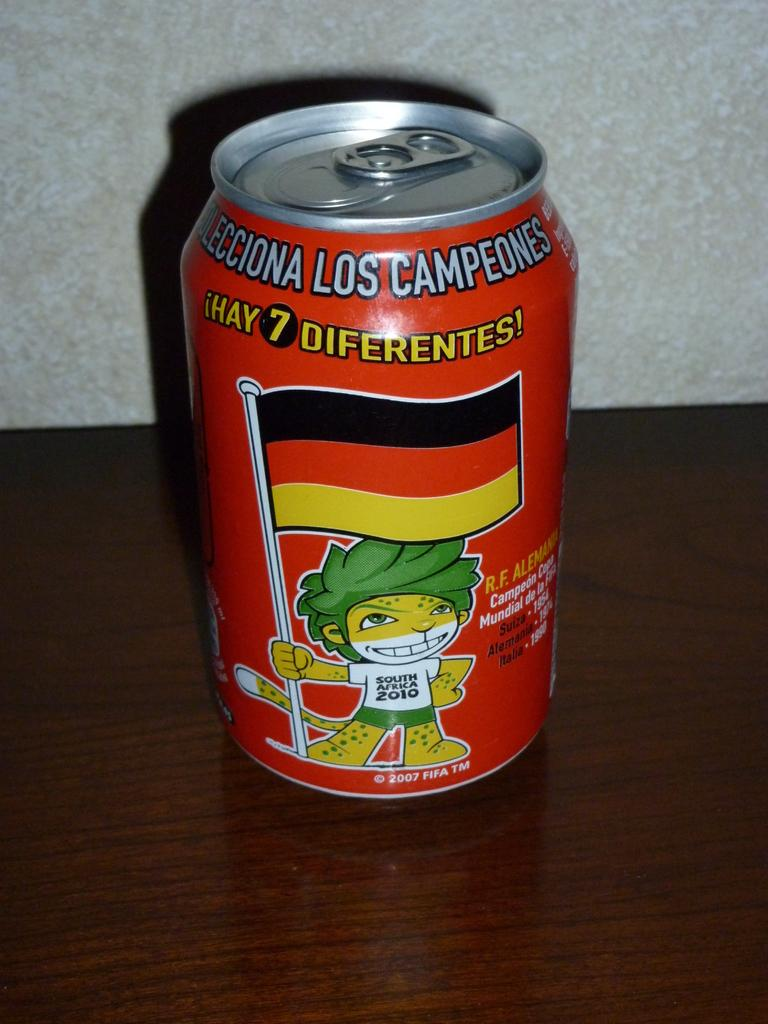<image>
Summarize the visual content of the image. A can of soda with a character wearing a shirt that says South Africa 2010 holding a German flag. 